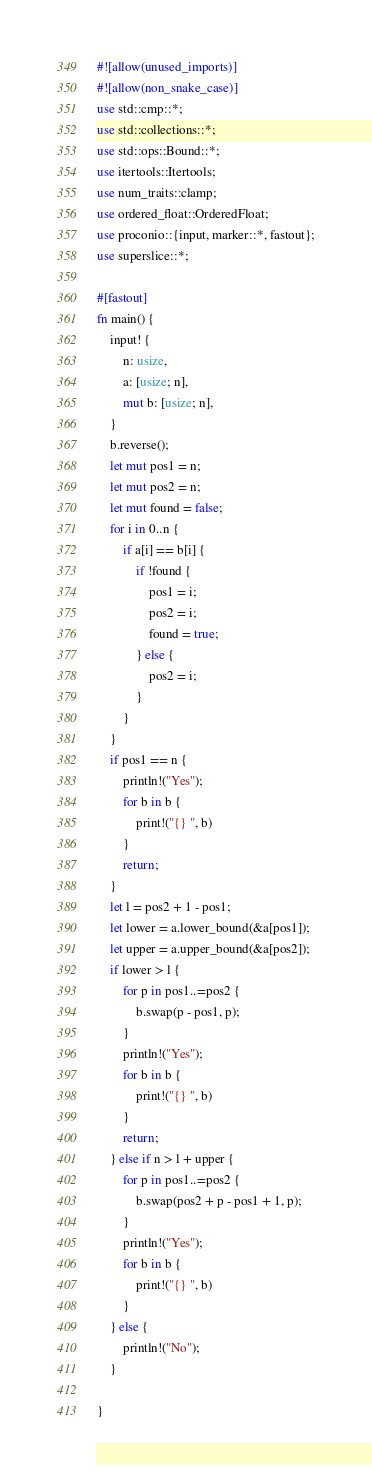Convert code to text. <code><loc_0><loc_0><loc_500><loc_500><_Rust_>#![allow(unused_imports)]
#![allow(non_snake_case)]
use std::cmp::*;
use std::collections::*;
use std::ops::Bound::*;
use itertools::Itertools;
use num_traits::clamp;
use ordered_float::OrderedFloat;
use proconio::{input, marker::*, fastout};
use superslice::*;

#[fastout]
fn main() {
    input! {
        n: usize,
        a: [usize; n],
        mut b: [usize; n],
    }
    b.reverse();
    let mut pos1 = n;
    let mut pos2 = n;
    let mut found = false;
    for i in 0..n {
        if a[i] == b[i] {
            if !found {
                pos1 = i;
                pos2 = i;
                found = true;
            } else {
                pos2 = i;
            }
        }
    }
    if pos1 == n {
        println!("Yes");
        for b in b {
            print!("{} ", b)
        }
        return;
    }
    let l = pos2 + 1 - pos1;
    let lower = a.lower_bound(&a[pos1]);
    let upper = a.upper_bound(&a[pos2]);
    if lower > l {
        for p in pos1..=pos2 {
            b.swap(p - pos1, p);
        }
        println!("Yes");
        for b in b {
            print!("{} ", b)
        }
        return;
    } else if n > l + upper {
        for p in pos1..=pos2 {
            b.swap(pos2 + p - pos1 + 1, p);
        }
        println!("Yes");
        for b in b {
            print!("{} ", b)
        }
    } else {
        println!("No");
    }

}
</code> 